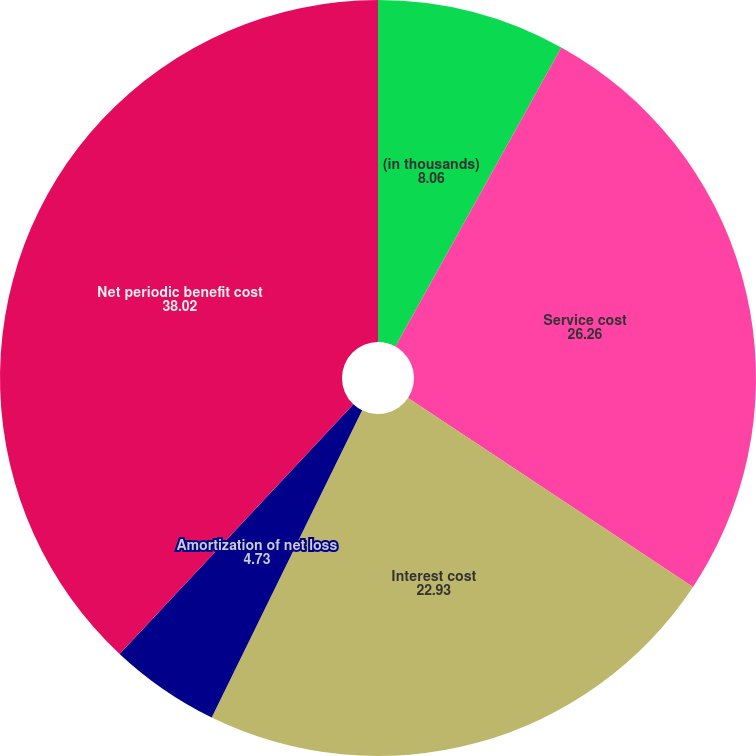Convert chart. <chart><loc_0><loc_0><loc_500><loc_500><pie_chart><fcel>(in thousands)<fcel>Service cost<fcel>Interest cost<fcel>Amortization of net loss<fcel>Net periodic benefit cost<nl><fcel>8.06%<fcel>26.26%<fcel>22.93%<fcel>4.73%<fcel>38.02%<nl></chart> 